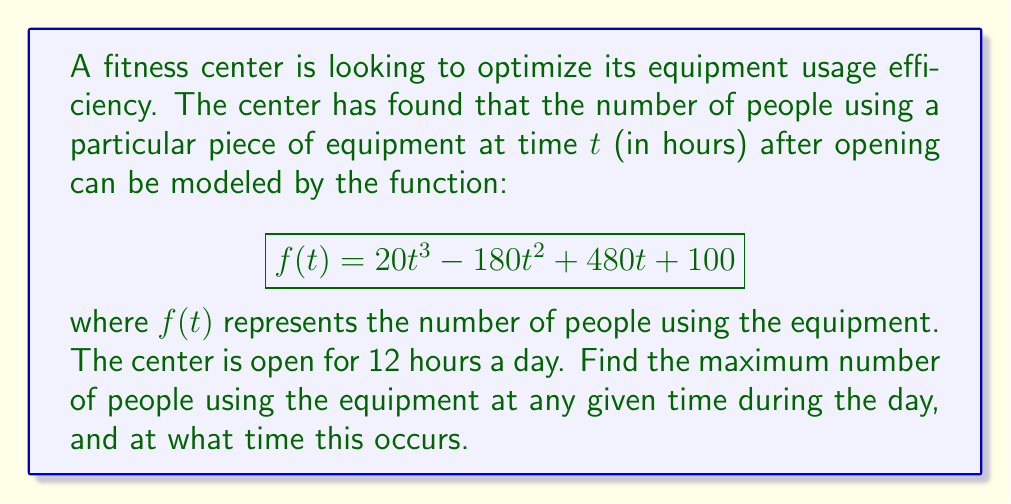What is the answer to this math problem? To solve this problem, we need to find the maximum value of the function $f(t)$ in the interval $[0, 12]$. This can be done using calculus by following these steps:

1) First, we need to find the critical points of the function. These occur where the derivative $f'(t)$ is zero or undefined.

2) Calculate the derivative:
   $$f'(t) = 60t^2 - 360t + 480$$

3) Set $f'(t) = 0$ and solve for $t$:
   $$60t^2 - 360t + 480 = 0$$
   $$t^2 - 6t + 8 = 0$$
   $$(t - 4)(t - 2) = 0$$
   $$t = 4 \text{ or } t = 2$$

4) Both of these critical points are within our interval $[0, 12]$.

5) Now we need to evaluate $f(t)$ at these critical points and at the endpoints of the interval:

   At $t = 0$: $f(0) = 100$
   At $t = 2$: $f(2) = 20(2^3) - 180(2^2) + 480(2) + 100 = 580$
   At $t = 4$: $f(4) = 20(4^3) - 180(4^2) + 480(4) + 100 = 740$
   At $t = 12$: $f(12) = 20(12^3) - 180(12^2) + 480(12) + 100 = 10,660$

6) The maximum value among these is 10,660, which occurs at $t = 12$.

Therefore, the maximum number of people using the equipment is 10,660, and this occurs 12 hours after opening (i.e., at closing time).
Answer: The maximum number of people using the equipment is 10,660, occurring 12 hours after opening. 